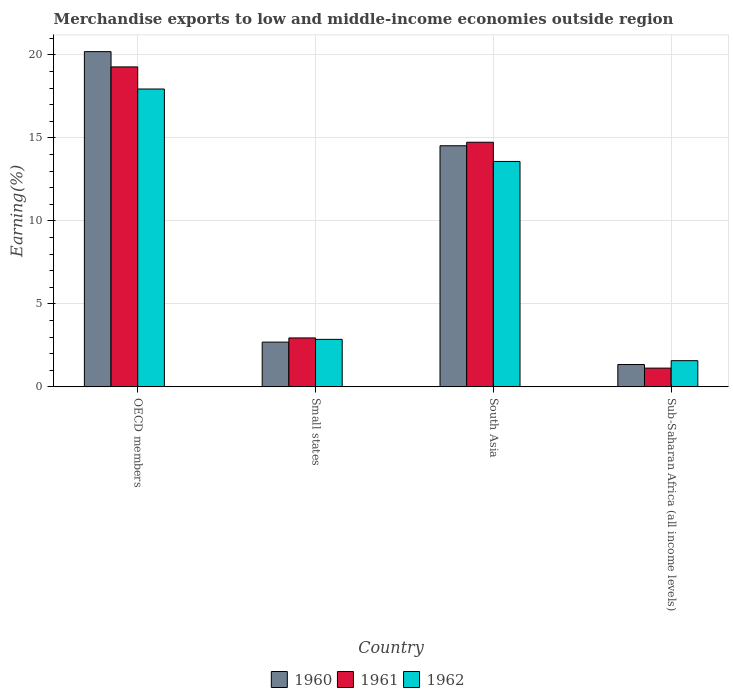Are the number of bars per tick equal to the number of legend labels?
Give a very brief answer. Yes. What is the label of the 2nd group of bars from the left?
Your response must be concise. Small states. What is the percentage of amount earned from merchandise exports in 1961 in Sub-Saharan Africa (all income levels)?
Provide a succinct answer. 1.13. Across all countries, what is the maximum percentage of amount earned from merchandise exports in 1961?
Ensure brevity in your answer.  19.27. Across all countries, what is the minimum percentage of amount earned from merchandise exports in 1962?
Provide a short and direct response. 1.58. In which country was the percentage of amount earned from merchandise exports in 1962 minimum?
Your answer should be very brief. Sub-Saharan Africa (all income levels). What is the total percentage of amount earned from merchandise exports in 1961 in the graph?
Offer a terse response. 38.08. What is the difference between the percentage of amount earned from merchandise exports in 1960 in OECD members and that in South Asia?
Your answer should be compact. 5.67. What is the difference between the percentage of amount earned from merchandise exports in 1960 in Small states and the percentage of amount earned from merchandise exports in 1961 in Sub-Saharan Africa (all income levels)?
Your answer should be very brief. 1.57. What is the average percentage of amount earned from merchandise exports in 1961 per country?
Your response must be concise. 9.52. What is the difference between the percentage of amount earned from merchandise exports of/in 1962 and percentage of amount earned from merchandise exports of/in 1960 in Sub-Saharan Africa (all income levels)?
Your answer should be very brief. 0.23. In how many countries, is the percentage of amount earned from merchandise exports in 1961 greater than 12 %?
Make the answer very short. 2. What is the ratio of the percentage of amount earned from merchandise exports in 1960 in OECD members to that in Small states?
Offer a very short reply. 7.49. Is the percentage of amount earned from merchandise exports in 1962 in South Asia less than that in Sub-Saharan Africa (all income levels)?
Offer a terse response. No. What is the difference between the highest and the second highest percentage of amount earned from merchandise exports in 1961?
Provide a succinct answer. -16.32. What is the difference between the highest and the lowest percentage of amount earned from merchandise exports in 1961?
Ensure brevity in your answer.  18.14. Is the sum of the percentage of amount earned from merchandise exports in 1960 in Small states and South Asia greater than the maximum percentage of amount earned from merchandise exports in 1962 across all countries?
Give a very brief answer. No. What does the 1st bar from the left in OECD members represents?
Ensure brevity in your answer.  1960. Is it the case that in every country, the sum of the percentage of amount earned from merchandise exports in 1961 and percentage of amount earned from merchandise exports in 1960 is greater than the percentage of amount earned from merchandise exports in 1962?
Ensure brevity in your answer.  Yes. How many countries are there in the graph?
Provide a short and direct response. 4. Does the graph contain any zero values?
Your answer should be very brief. No. How many legend labels are there?
Your answer should be very brief. 3. How are the legend labels stacked?
Your response must be concise. Horizontal. What is the title of the graph?
Your response must be concise. Merchandise exports to low and middle-income economies outside region. Does "1962" appear as one of the legend labels in the graph?
Your answer should be compact. Yes. What is the label or title of the Y-axis?
Keep it short and to the point. Earning(%). What is the Earning(%) in 1960 in OECD members?
Your answer should be compact. 20.19. What is the Earning(%) of 1961 in OECD members?
Keep it short and to the point. 19.27. What is the Earning(%) in 1962 in OECD members?
Offer a terse response. 17.94. What is the Earning(%) in 1960 in Small states?
Offer a terse response. 2.7. What is the Earning(%) of 1961 in Small states?
Offer a very short reply. 2.95. What is the Earning(%) of 1962 in Small states?
Provide a short and direct response. 2.86. What is the Earning(%) in 1960 in South Asia?
Provide a short and direct response. 14.52. What is the Earning(%) of 1961 in South Asia?
Your response must be concise. 14.73. What is the Earning(%) in 1962 in South Asia?
Offer a terse response. 13.58. What is the Earning(%) in 1960 in Sub-Saharan Africa (all income levels)?
Your answer should be compact. 1.35. What is the Earning(%) in 1961 in Sub-Saharan Africa (all income levels)?
Make the answer very short. 1.13. What is the Earning(%) of 1962 in Sub-Saharan Africa (all income levels)?
Give a very brief answer. 1.58. Across all countries, what is the maximum Earning(%) of 1960?
Offer a very short reply. 20.19. Across all countries, what is the maximum Earning(%) in 1961?
Give a very brief answer. 19.27. Across all countries, what is the maximum Earning(%) of 1962?
Make the answer very short. 17.94. Across all countries, what is the minimum Earning(%) of 1960?
Make the answer very short. 1.35. Across all countries, what is the minimum Earning(%) of 1961?
Your answer should be compact. 1.13. Across all countries, what is the minimum Earning(%) in 1962?
Offer a terse response. 1.58. What is the total Earning(%) in 1960 in the graph?
Offer a very short reply. 38.76. What is the total Earning(%) in 1961 in the graph?
Your answer should be very brief. 38.08. What is the total Earning(%) in 1962 in the graph?
Provide a succinct answer. 35.96. What is the difference between the Earning(%) of 1960 in OECD members and that in Small states?
Offer a very short reply. 17.5. What is the difference between the Earning(%) of 1961 in OECD members and that in Small states?
Your response must be concise. 16.32. What is the difference between the Earning(%) of 1962 in OECD members and that in Small states?
Ensure brevity in your answer.  15.08. What is the difference between the Earning(%) of 1960 in OECD members and that in South Asia?
Provide a succinct answer. 5.67. What is the difference between the Earning(%) in 1961 in OECD members and that in South Asia?
Offer a very short reply. 4.54. What is the difference between the Earning(%) of 1962 in OECD members and that in South Asia?
Keep it short and to the point. 4.36. What is the difference between the Earning(%) in 1960 in OECD members and that in Sub-Saharan Africa (all income levels)?
Offer a very short reply. 18.84. What is the difference between the Earning(%) in 1961 in OECD members and that in Sub-Saharan Africa (all income levels)?
Your response must be concise. 18.14. What is the difference between the Earning(%) in 1962 in OECD members and that in Sub-Saharan Africa (all income levels)?
Offer a terse response. 16.36. What is the difference between the Earning(%) of 1960 in Small states and that in South Asia?
Keep it short and to the point. -11.83. What is the difference between the Earning(%) in 1961 in Small states and that in South Asia?
Your answer should be very brief. -11.79. What is the difference between the Earning(%) in 1962 in Small states and that in South Asia?
Provide a succinct answer. -10.72. What is the difference between the Earning(%) in 1960 in Small states and that in Sub-Saharan Africa (all income levels)?
Your answer should be very brief. 1.35. What is the difference between the Earning(%) in 1961 in Small states and that in Sub-Saharan Africa (all income levels)?
Your answer should be compact. 1.82. What is the difference between the Earning(%) in 1962 in Small states and that in Sub-Saharan Africa (all income levels)?
Provide a succinct answer. 1.28. What is the difference between the Earning(%) in 1960 in South Asia and that in Sub-Saharan Africa (all income levels)?
Your answer should be compact. 13.18. What is the difference between the Earning(%) of 1961 in South Asia and that in Sub-Saharan Africa (all income levels)?
Offer a very short reply. 13.6. What is the difference between the Earning(%) of 1962 in South Asia and that in Sub-Saharan Africa (all income levels)?
Your answer should be very brief. 12. What is the difference between the Earning(%) of 1960 in OECD members and the Earning(%) of 1961 in Small states?
Your response must be concise. 17.24. What is the difference between the Earning(%) of 1960 in OECD members and the Earning(%) of 1962 in Small states?
Provide a short and direct response. 17.33. What is the difference between the Earning(%) of 1961 in OECD members and the Earning(%) of 1962 in Small states?
Provide a succinct answer. 16.41. What is the difference between the Earning(%) of 1960 in OECD members and the Earning(%) of 1961 in South Asia?
Ensure brevity in your answer.  5.46. What is the difference between the Earning(%) of 1960 in OECD members and the Earning(%) of 1962 in South Asia?
Provide a succinct answer. 6.61. What is the difference between the Earning(%) in 1961 in OECD members and the Earning(%) in 1962 in South Asia?
Offer a very short reply. 5.69. What is the difference between the Earning(%) of 1960 in OECD members and the Earning(%) of 1961 in Sub-Saharan Africa (all income levels)?
Provide a short and direct response. 19.06. What is the difference between the Earning(%) in 1960 in OECD members and the Earning(%) in 1962 in Sub-Saharan Africa (all income levels)?
Make the answer very short. 18.61. What is the difference between the Earning(%) of 1961 in OECD members and the Earning(%) of 1962 in Sub-Saharan Africa (all income levels)?
Ensure brevity in your answer.  17.69. What is the difference between the Earning(%) in 1960 in Small states and the Earning(%) in 1961 in South Asia?
Keep it short and to the point. -12.04. What is the difference between the Earning(%) in 1960 in Small states and the Earning(%) in 1962 in South Asia?
Provide a succinct answer. -10.88. What is the difference between the Earning(%) in 1961 in Small states and the Earning(%) in 1962 in South Asia?
Ensure brevity in your answer.  -10.63. What is the difference between the Earning(%) of 1960 in Small states and the Earning(%) of 1961 in Sub-Saharan Africa (all income levels)?
Your answer should be compact. 1.57. What is the difference between the Earning(%) of 1960 in Small states and the Earning(%) of 1962 in Sub-Saharan Africa (all income levels)?
Your response must be concise. 1.12. What is the difference between the Earning(%) of 1961 in Small states and the Earning(%) of 1962 in Sub-Saharan Africa (all income levels)?
Provide a succinct answer. 1.37. What is the difference between the Earning(%) of 1960 in South Asia and the Earning(%) of 1961 in Sub-Saharan Africa (all income levels)?
Offer a very short reply. 13.39. What is the difference between the Earning(%) of 1960 in South Asia and the Earning(%) of 1962 in Sub-Saharan Africa (all income levels)?
Keep it short and to the point. 12.94. What is the difference between the Earning(%) of 1961 in South Asia and the Earning(%) of 1962 in Sub-Saharan Africa (all income levels)?
Provide a succinct answer. 13.16. What is the average Earning(%) of 1960 per country?
Ensure brevity in your answer.  9.69. What is the average Earning(%) in 1961 per country?
Provide a short and direct response. 9.52. What is the average Earning(%) in 1962 per country?
Ensure brevity in your answer.  8.99. What is the difference between the Earning(%) in 1960 and Earning(%) in 1961 in OECD members?
Make the answer very short. 0.92. What is the difference between the Earning(%) of 1960 and Earning(%) of 1962 in OECD members?
Offer a very short reply. 2.25. What is the difference between the Earning(%) in 1961 and Earning(%) in 1962 in OECD members?
Make the answer very short. 1.33. What is the difference between the Earning(%) in 1960 and Earning(%) in 1961 in Small states?
Make the answer very short. -0.25. What is the difference between the Earning(%) of 1960 and Earning(%) of 1962 in Small states?
Give a very brief answer. -0.17. What is the difference between the Earning(%) of 1961 and Earning(%) of 1962 in Small states?
Make the answer very short. 0.09. What is the difference between the Earning(%) in 1960 and Earning(%) in 1961 in South Asia?
Offer a very short reply. -0.21. What is the difference between the Earning(%) of 1961 and Earning(%) of 1962 in South Asia?
Provide a short and direct response. 1.16. What is the difference between the Earning(%) in 1960 and Earning(%) in 1961 in Sub-Saharan Africa (all income levels)?
Ensure brevity in your answer.  0.22. What is the difference between the Earning(%) of 1960 and Earning(%) of 1962 in Sub-Saharan Africa (all income levels)?
Your response must be concise. -0.23. What is the difference between the Earning(%) of 1961 and Earning(%) of 1962 in Sub-Saharan Africa (all income levels)?
Offer a very short reply. -0.45. What is the ratio of the Earning(%) of 1960 in OECD members to that in Small states?
Offer a very short reply. 7.49. What is the ratio of the Earning(%) in 1961 in OECD members to that in Small states?
Give a very brief answer. 6.54. What is the ratio of the Earning(%) of 1962 in OECD members to that in Small states?
Offer a very short reply. 6.27. What is the ratio of the Earning(%) of 1960 in OECD members to that in South Asia?
Provide a short and direct response. 1.39. What is the ratio of the Earning(%) in 1961 in OECD members to that in South Asia?
Offer a very short reply. 1.31. What is the ratio of the Earning(%) of 1962 in OECD members to that in South Asia?
Make the answer very short. 1.32. What is the ratio of the Earning(%) in 1960 in OECD members to that in Sub-Saharan Africa (all income levels)?
Offer a terse response. 15. What is the ratio of the Earning(%) of 1961 in OECD members to that in Sub-Saharan Africa (all income levels)?
Your response must be concise. 17.06. What is the ratio of the Earning(%) in 1962 in OECD members to that in Sub-Saharan Africa (all income levels)?
Give a very brief answer. 11.36. What is the ratio of the Earning(%) in 1960 in Small states to that in South Asia?
Give a very brief answer. 0.19. What is the ratio of the Earning(%) of 1961 in Small states to that in South Asia?
Provide a short and direct response. 0.2. What is the ratio of the Earning(%) of 1962 in Small states to that in South Asia?
Offer a very short reply. 0.21. What is the ratio of the Earning(%) in 1960 in Small states to that in Sub-Saharan Africa (all income levels)?
Ensure brevity in your answer.  2. What is the ratio of the Earning(%) of 1961 in Small states to that in Sub-Saharan Africa (all income levels)?
Your answer should be compact. 2.61. What is the ratio of the Earning(%) of 1962 in Small states to that in Sub-Saharan Africa (all income levels)?
Make the answer very short. 1.81. What is the ratio of the Earning(%) in 1960 in South Asia to that in Sub-Saharan Africa (all income levels)?
Offer a terse response. 10.79. What is the ratio of the Earning(%) in 1961 in South Asia to that in Sub-Saharan Africa (all income levels)?
Your answer should be compact. 13.04. What is the ratio of the Earning(%) of 1962 in South Asia to that in Sub-Saharan Africa (all income levels)?
Your response must be concise. 8.6. What is the difference between the highest and the second highest Earning(%) of 1960?
Your response must be concise. 5.67. What is the difference between the highest and the second highest Earning(%) in 1961?
Make the answer very short. 4.54. What is the difference between the highest and the second highest Earning(%) in 1962?
Your answer should be very brief. 4.36. What is the difference between the highest and the lowest Earning(%) in 1960?
Give a very brief answer. 18.84. What is the difference between the highest and the lowest Earning(%) of 1961?
Your answer should be compact. 18.14. What is the difference between the highest and the lowest Earning(%) in 1962?
Your answer should be compact. 16.36. 